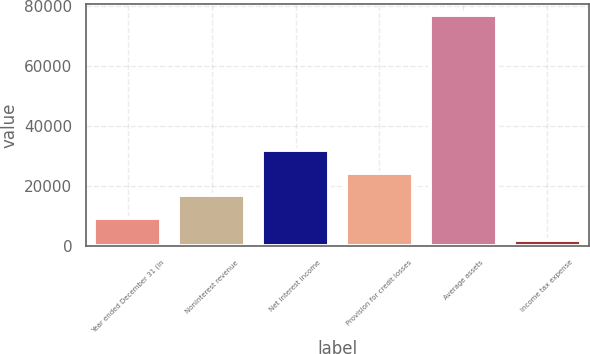<chart> <loc_0><loc_0><loc_500><loc_500><bar_chart><fcel>Year ended December 31 (in<fcel>Noninterest revenue<fcel>Net interest income<fcel>Provision for credit losses<fcel>Average assets<fcel>Income tax expense<nl><fcel>9407.6<fcel>16907.2<fcel>31906.4<fcel>24406.8<fcel>76904<fcel>1908<nl></chart> 